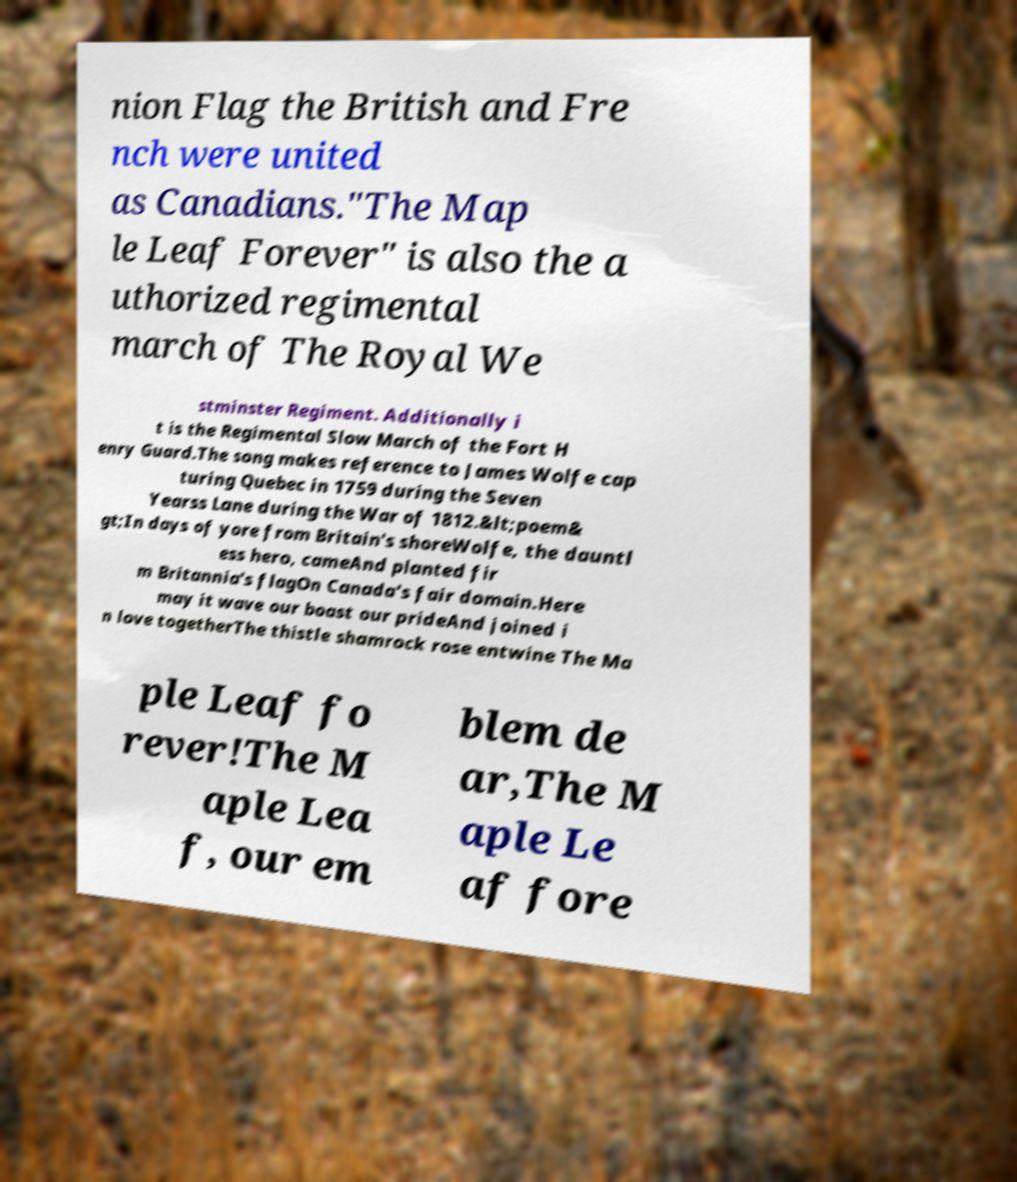There's text embedded in this image that I need extracted. Can you transcribe it verbatim? nion Flag the British and Fre nch were united as Canadians."The Map le Leaf Forever" is also the a uthorized regimental march of The Royal We stminster Regiment. Additionally i t is the Regimental Slow March of the Fort H enry Guard.The song makes reference to James Wolfe cap turing Quebec in 1759 during the Seven Yearss Lane during the War of 1812.&lt;poem& gt;In days of yore from Britain's shoreWolfe, the dauntl ess hero, cameAnd planted fir m Britannia's flagOn Canada's fair domain.Here may it wave our boast our prideAnd joined i n love togetherThe thistle shamrock rose entwine The Ma ple Leaf fo rever!The M aple Lea f, our em blem de ar,The M aple Le af fore 